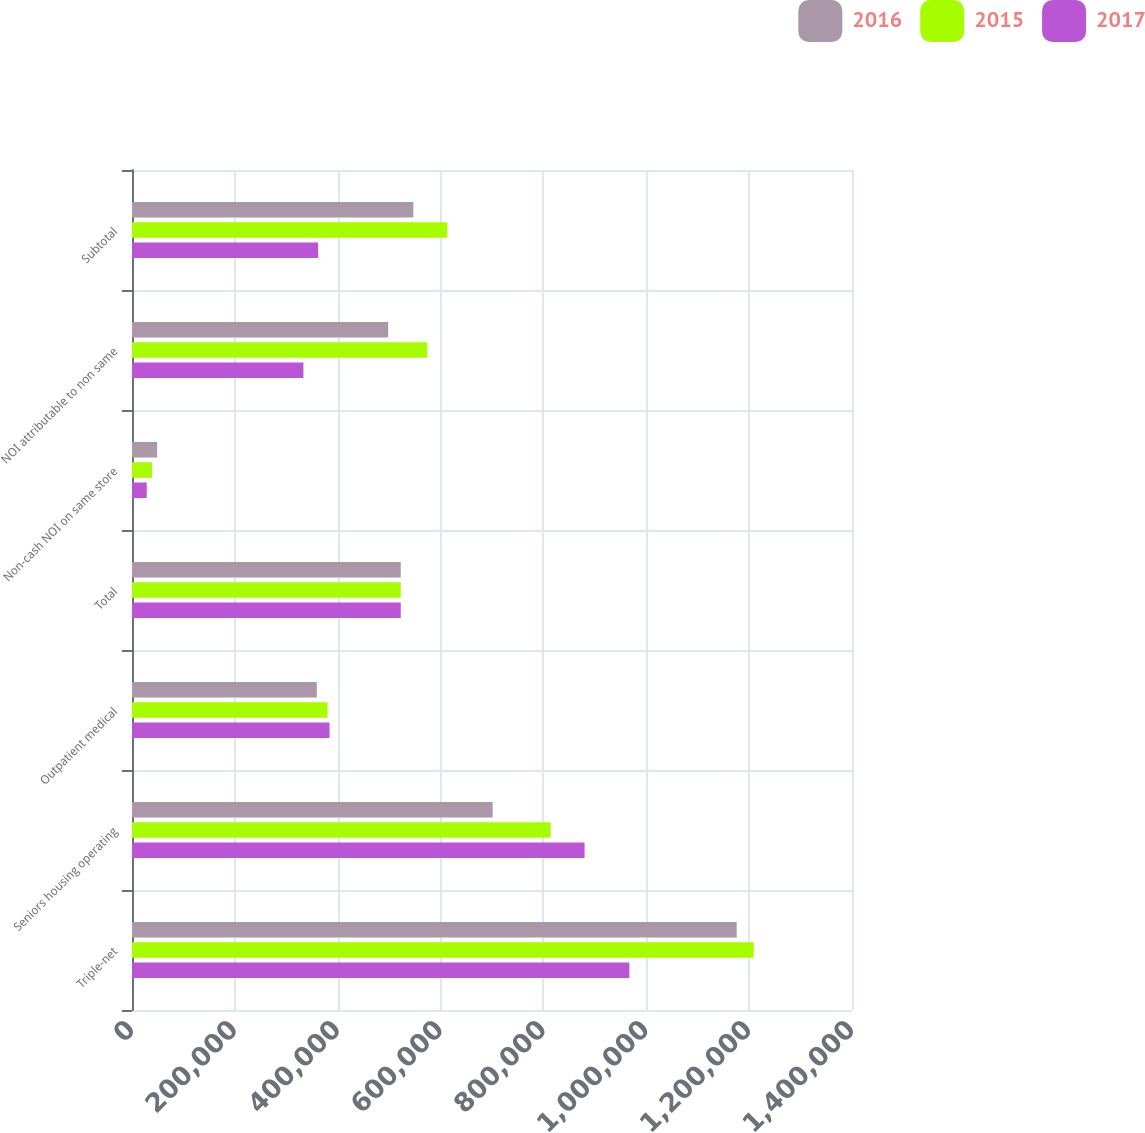Convert chart to OTSL. <chart><loc_0><loc_0><loc_500><loc_500><stacked_bar_chart><ecel><fcel>Triple-net<fcel>Seniors housing operating<fcel>Outpatient medical<fcel>Total<fcel>Non-cash NOI on same store<fcel>NOI attributable to non same<fcel>Subtotal<nl><fcel>2016<fcel>1.17581e+06<fcel>701262<fcel>359410<fcel>522576<fcel>48890<fcel>498131<fcel>547021<nl><fcel>2015<fcel>1.20886e+06<fcel>814114<fcel>380264<fcel>522576<fcel>38899<fcel>574049<fcel>612948<nl><fcel>2017<fcel>967084<fcel>880026<fcel>384068<fcel>522576<fcel>28602<fcel>333279<fcel>361881<nl></chart> 